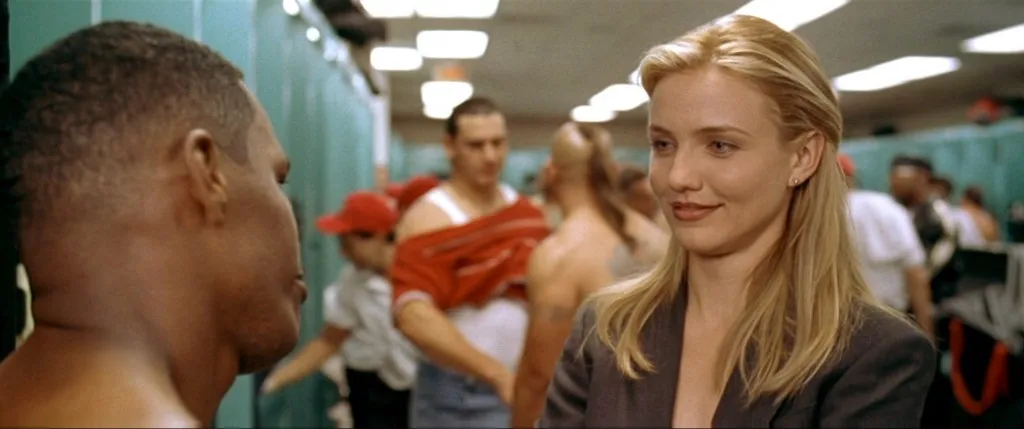Imagine a backstory for these characters outside of a sports context. In a different context, one could imagine the woman as a legal or business professional consulting with the man, who might be a client or colleague. Their discussion, while serious, gives the impression of mutual respect and hints at an important decision or turning point in their professional relationship. 